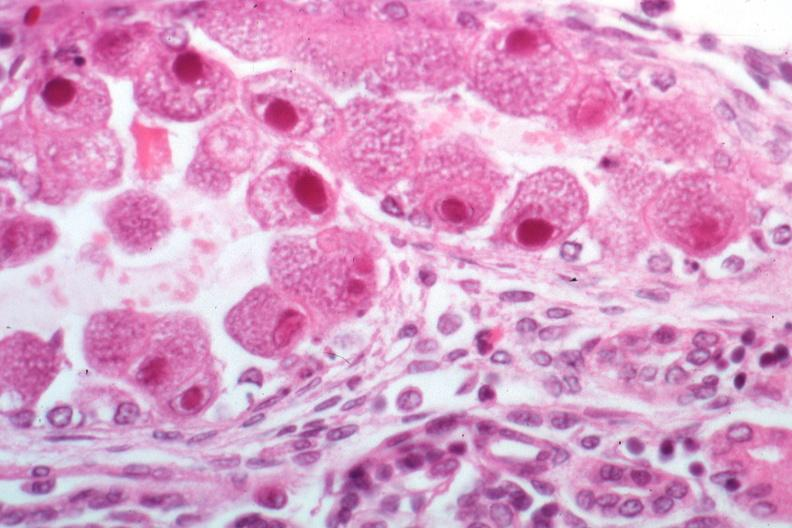what is present?
Answer the question using a single word or phrase. Kidney 